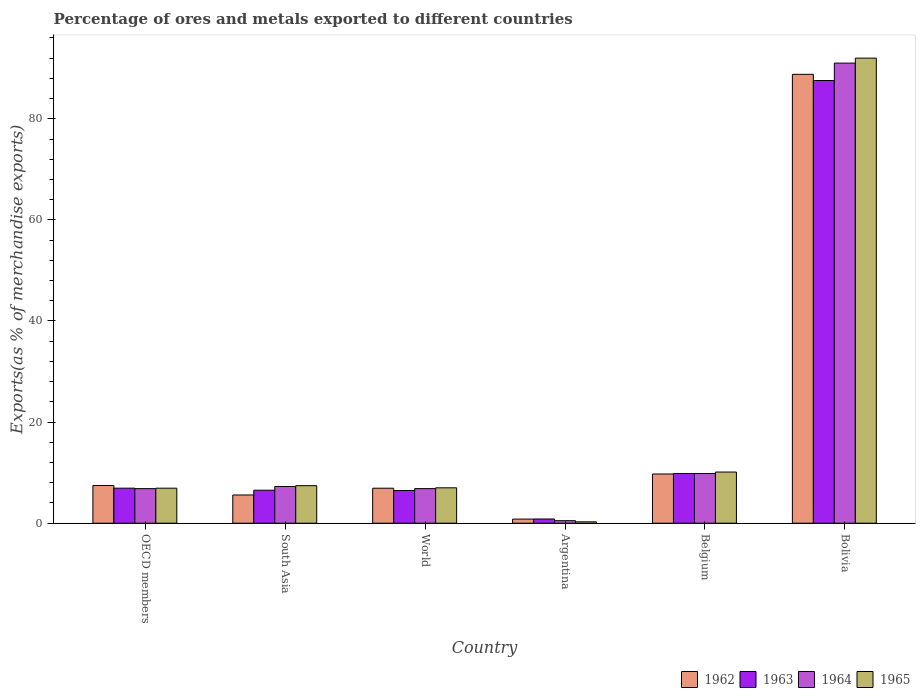How many different coloured bars are there?
Make the answer very short. 4. How many groups of bars are there?
Your response must be concise. 6. Are the number of bars per tick equal to the number of legend labels?
Offer a very short reply. Yes. How many bars are there on the 6th tick from the right?
Make the answer very short. 4. In how many cases, is the number of bars for a given country not equal to the number of legend labels?
Provide a succinct answer. 0. What is the percentage of exports to different countries in 1962 in Belgium?
Your answer should be very brief. 9.73. Across all countries, what is the maximum percentage of exports to different countries in 1965?
Your answer should be very brief. 92. Across all countries, what is the minimum percentage of exports to different countries in 1962?
Make the answer very short. 0.81. In which country was the percentage of exports to different countries in 1965 maximum?
Give a very brief answer. Bolivia. What is the total percentage of exports to different countries in 1965 in the graph?
Keep it short and to the point. 123.74. What is the difference between the percentage of exports to different countries in 1963 in Argentina and that in OECD members?
Offer a very short reply. -6.1. What is the difference between the percentage of exports to different countries in 1962 in Argentina and the percentage of exports to different countries in 1964 in South Asia?
Your response must be concise. -6.45. What is the average percentage of exports to different countries in 1963 per country?
Provide a short and direct response. 19.69. What is the difference between the percentage of exports to different countries of/in 1964 and percentage of exports to different countries of/in 1963 in World?
Offer a very short reply. 0.38. In how many countries, is the percentage of exports to different countries in 1964 greater than 56 %?
Your answer should be compact. 1. What is the ratio of the percentage of exports to different countries in 1962 in Argentina to that in Bolivia?
Keep it short and to the point. 0.01. Is the difference between the percentage of exports to different countries in 1964 in Argentina and OECD members greater than the difference between the percentage of exports to different countries in 1963 in Argentina and OECD members?
Your answer should be very brief. No. What is the difference between the highest and the second highest percentage of exports to different countries in 1962?
Your response must be concise. 79.06. What is the difference between the highest and the lowest percentage of exports to different countries in 1962?
Provide a short and direct response. 87.98. Is the sum of the percentage of exports to different countries in 1963 in South Asia and World greater than the maximum percentage of exports to different countries in 1962 across all countries?
Offer a very short reply. No. Is it the case that in every country, the sum of the percentage of exports to different countries in 1964 and percentage of exports to different countries in 1963 is greater than the sum of percentage of exports to different countries in 1965 and percentage of exports to different countries in 1962?
Make the answer very short. No. What does the 1st bar from the right in OECD members represents?
Keep it short and to the point. 1965. How many bars are there?
Provide a short and direct response. 24. Are all the bars in the graph horizontal?
Ensure brevity in your answer.  No. How many countries are there in the graph?
Give a very brief answer. 6. Are the values on the major ticks of Y-axis written in scientific E-notation?
Provide a short and direct response. No. Does the graph contain any zero values?
Your answer should be very brief. No. How are the legend labels stacked?
Keep it short and to the point. Horizontal. What is the title of the graph?
Give a very brief answer. Percentage of ores and metals exported to different countries. Does "1961" appear as one of the legend labels in the graph?
Your answer should be compact. No. What is the label or title of the X-axis?
Make the answer very short. Country. What is the label or title of the Y-axis?
Provide a short and direct response. Exports(as % of merchandise exports). What is the Exports(as % of merchandise exports) of 1962 in OECD members?
Offer a very short reply. 7.46. What is the Exports(as % of merchandise exports) in 1963 in OECD members?
Ensure brevity in your answer.  6.93. What is the Exports(as % of merchandise exports) in 1964 in OECD members?
Offer a very short reply. 6.84. What is the Exports(as % of merchandise exports) of 1965 in OECD members?
Make the answer very short. 6.93. What is the Exports(as % of merchandise exports) of 1962 in South Asia?
Keep it short and to the point. 5.58. What is the Exports(as % of merchandise exports) in 1963 in South Asia?
Your response must be concise. 6.52. What is the Exports(as % of merchandise exports) of 1964 in South Asia?
Offer a very short reply. 7.26. What is the Exports(as % of merchandise exports) in 1965 in South Asia?
Offer a very short reply. 7.42. What is the Exports(as % of merchandise exports) in 1962 in World?
Ensure brevity in your answer.  6.92. What is the Exports(as % of merchandise exports) of 1963 in World?
Ensure brevity in your answer.  6.46. What is the Exports(as % of merchandise exports) of 1964 in World?
Give a very brief answer. 6.84. What is the Exports(as % of merchandise exports) in 1965 in World?
Offer a very short reply. 7. What is the Exports(as % of merchandise exports) in 1962 in Argentina?
Your response must be concise. 0.81. What is the Exports(as % of merchandise exports) of 1963 in Argentina?
Your answer should be very brief. 0.83. What is the Exports(as % of merchandise exports) in 1964 in Argentina?
Offer a very short reply. 0.5. What is the Exports(as % of merchandise exports) of 1965 in Argentina?
Your answer should be compact. 0.27. What is the Exports(as % of merchandise exports) of 1962 in Belgium?
Your response must be concise. 9.73. What is the Exports(as % of merchandise exports) of 1963 in Belgium?
Your answer should be very brief. 9.84. What is the Exports(as % of merchandise exports) in 1964 in Belgium?
Your answer should be very brief. 9.83. What is the Exports(as % of merchandise exports) of 1965 in Belgium?
Your response must be concise. 10.12. What is the Exports(as % of merchandise exports) in 1962 in Bolivia?
Your answer should be very brief. 88.79. What is the Exports(as % of merchandise exports) of 1963 in Bolivia?
Your response must be concise. 87.57. What is the Exports(as % of merchandise exports) of 1964 in Bolivia?
Offer a terse response. 91.02. What is the Exports(as % of merchandise exports) in 1965 in Bolivia?
Provide a succinct answer. 92. Across all countries, what is the maximum Exports(as % of merchandise exports) of 1962?
Offer a very short reply. 88.79. Across all countries, what is the maximum Exports(as % of merchandise exports) in 1963?
Provide a succinct answer. 87.57. Across all countries, what is the maximum Exports(as % of merchandise exports) in 1964?
Make the answer very short. 91.02. Across all countries, what is the maximum Exports(as % of merchandise exports) of 1965?
Your response must be concise. 92. Across all countries, what is the minimum Exports(as % of merchandise exports) of 1962?
Offer a terse response. 0.81. Across all countries, what is the minimum Exports(as % of merchandise exports) of 1963?
Your answer should be very brief. 0.83. Across all countries, what is the minimum Exports(as % of merchandise exports) of 1964?
Ensure brevity in your answer.  0.5. Across all countries, what is the minimum Exports(as % of merchandise exports) of 1965?
Provide a succinct answer. 0.27. What is the total Exports(as % of merchandise exports) in 1962 in the graph?
Make the answer very short. 119.31. What is the total Exports(as % of merchandise exports) in 1963 in the graph?
Your response must be concise. 118.16. What is the total Exports(as % of merchandise exports) of 1964 in the graph?
Provide a succinct answer. 122.28. What is the total Exports(as % of merchandise exports) of 1965 in the graph?
Your answer should be very brief. 123.74. What is the difference between the Exports(as % of merchandise exports) in 1962 in OECD members and that in South Asia?
Your response must be concise. 1.88. What is the difference between the Exports(as % of merchandise exports) of 1963 in OECD members and that in South Asia?
Provide a succinct answer. 0.41. What is the difference between the Exports(as % of merchandise exports) in 1964 in OECD members and that in South Asia?
Your answer should be very brief. -0.42. What is the difference between the Exports(as % of merchandise exports) of 1965 in OECD members and that in South Asia?
Make the answer very short. -0.5. What is the difference between the Exports(as % of merchandise exports) of 1962 in OECD members and that in World?
Your response must be concise. 0.54. What is the difference between the Exports(as % of merchandise exports) of 1963 in OECD members and that in World?
Provide a short and direct response. 0.47. What is the difference between the Exports(as % of merchandise exports) of 1964 in OECD members and that in World?
Your answer should be compact. -0. What is the difference between the Exports(as % of merchandise exports) of 1965 in OECD members and that in World?
Your answer should be compact. -0.07. What is the difference between the Exports(as % of merchandise exports) of 1962 in OECD members and that in Argentina?
Provide a short and direct response. 6.65. What is the difference between the Exports(as % of merchandise exports) in 1963 in OECD members and that in Argentina?
Offer a very short reply. 6.1. What is the difference between the Exports(as % of merchandise exports) in 1964 in OECD members and that in Argentina?
Offer a terse response. 6.34. What is the difference between the Exports(as % of merchandise exports) of 1965 in OECD members and that in Argentina?
Give a very brief answer. 6.66. What is the difference between the Exports(as % of merchandise exports) of 1962 in OECD members and that in Belgium?
Your answer should be very brief. -2.27. What is the difference between the Exports(as % of merchandise exports) of 1963 in OECD members and that in Belgium?
Your response must be concise. -2.91. What is the difference between the Exports(as % of merchandise exports) of 1964 in OECD members and that in Belgium?
Your answer should be very brief. -2.99. What is the difference between the Exports(as % of merchandise exports) of 1965 in OECD members and that in Belgium?
Offer a terse response. -3.19. What is the difference between the Exports(as % of merchandise exports) of 1962 in OECD members and that in Bolivia?
Provide a succinct answer. -81.33. What is the difference between the Exports(as % of merchandise exports) of 1963 in OECD members and that in Bolivia?
Ensure brevity in your answer.  -80.64. What is the difference between the Exports(as % of merchandise exports) in 1964 in OECD members and that in Bolivia?
Ensure brevity in your answer.  -84.18. What is the difference between the Exports(as % of merchandise exports) in 1965 in OECD members and that in Bolivia?
Give a very brief answer. -85.07. What is the difference between the Exports(as % of merchandise exports) of 1962 in South Asia and that in World?
Offer a terse response. -1.34. What is the difference between the Exports(as % of merchandise exports) of 1963 in South Asia and that in World?
Your answer should be very brief. 0.06. What is the difference between the Exports(as % of merchandise exports) of 1964 in South Asia and that in World?
Give a very brief answer. 0.42. What is the difference between the Exports(as % of merchandise exports) in 1965 in South Asia and that in World?
Ensure brevity in your answer.  0.42. What is the difference between the Exports(as % of merchandise exports) of 1962 in South Asia and that in Argentina?
Your response must be concise. 4.77. What is the difference between the Exports(as % of merchandise exports) of 1963 in South Asia and that in Argentina?
Provide a short and direct response. 5.69. What is the difference between the Exports(as % of merchandise exports) in 1964 in South Asia and that in Argentina?
Keep it short and to the point. 6.76. What is the difference between the Exports(as % of merchandise exports) of 1965 in South Asia and that in Argentina?
Provide a short and direct response. 7.16. What is the difference between the Exports(as % of merchandise exports) of 1962 in South Asia and that in Belgium?
Provide a succinct answer. -4.15. What is the difference between the Exports(as % of merchandise exports) of 1963 in South Asia and that in Belgium?
Your answer should be compact. -3.32. What is the difference between the Exports(as % of merchandise exports) in 1964 in South Asia and that in Belgium?
Give a very brief answer. -2.57. What is the difference between the Exports(as % of merchandise exports) in 1965 in South Asia and that in Belgium?
Provide a short and direct response. -2.69. What is the difference between the Exports(as % of merchandise exports) in 1962 in South Asia and that in Bolivia?
Provide a succinct answer. -83.21. What is the difference between the Exports(as % of merchandise exports) in 1963 in South Asia and that in Bolivia?
Provide a succinct answer. -81.05. What is the difference between the Exports(as % of merchandise exports) in 1964 in South Asia and that in Bolivia?
Your answer should be compact. -83.76. What is the difference between the Exports(as % of merchandise exports) of 1965 in South Asia and that in Bolivia?
Provide a succinct answer. -84.58. What is the difference between the Exports(as % of merchandise exports) in 1962 in World and that in Argentina?
Your answer should be compact. 6.11. What is the difference between the Exports(as % of merchandise exports) in 1963 in World and that in Argentina?
Offer a terse response. 5.63. What is the difference between the Exports(as % of merchandise exports) in 1964 in World and that in Argentina?
Make the answer very short. 6.34. What is the difference between the Exports(as % of merchandise exports) in 1965 in World and that in Argentina?
Provide a short and direct response. 6.73. What is the difference between the Exports(as % of merchandise exports) of 1962 in World and that in Belgium?
Make the answer very short. -2.81. What is the difference between the Exports(as % of merchandise exports) of 1963 in World and that in Belgium?
Your answer should be very brief. -3.38. What is the difference between the Exports(as % of merchandise exports) in 1964 in World and that in Belgium?
Provide a succinct answer. -2.99. What is the difference between the Exports(as % of merchandise exports) of 1965 in World and that in Belgium?
Provide a short and direct response. -3.12. What is the difference between the Exports(as % of merchandise exports) of 1962 in World and that in Bolivia?
Make the answer very short. -81.87. What is the difference between the Exports(as % of merchandise exports) in 1963 in World and that in Bolivia?
Provide a short and direct response. -81.11. What is the difference between the Exports(as % of merchandise exports) in 1964 in World and that in Bolivia?
Give a very brief answer. -84.18. What is the difference between the Exports(as % of merchandise exports) in 1965 in World and that in Bolivia?
Offer a very short reply. -85. What is the difference between the Exports(as % of merchandise exports) of 1962 in Argentina and that in Belgium?
Ensure brevity in your answer.  -8.92. What is the difference between the Exports(as % of merchandise exports) of 1963 in Argentina and that in Belgium?
Provide a succinct answer. -9. What is the difference between the Exports(as % of merchandise exports) of 1964 in Argentina and that in Belgium?
Provide a short and direct response. -9.33. What is the difference between the Exports(as % of merchandise exports) in 1965 in Argentina and that in Belgium?
Provide a succinct answer. -9.85. What is the difference between the Exports(as % of merchandise exports) in 1962 in Argentina and that in Bolivia?
Give a very brief answer. -87.98. What is the difference between the Exports(as % of merchandise exports) in 1963 in Argentina and that in Bolivia?
Your answer should be very brief. -86.74. What is the difference between the Exports(as % of merchandise exports) of 1964 in Argentina and that in Bolivia?
Offer a terse response. -90.52. What is the difference between the Exports(as % of merchandise exports) of 1965 in Argentina and that in Bolivia?
Make the answer very short. -91.73. What is the difference between the Exports(as % of merchandise exports) of 1962 in Belgium and that in Bolivia?
Your answer should be compact. -79.06. What is the difference between the Exports(as % of merchandise exports) in 1963 in Belgium and that in Bolivia?
Your answer should be very brief. -77.73. What is the difference between the Exports(as % of merchandise exports) of 1964 in Belgium and that in Bolivia?
Provide a succinct answer. -81.19. What is the difference between the Exports(as % of merchandise exports) in 1965 in Belgium and that in Bolivia?
Your response must be concise. -81.88. What is the difference between the Exports(as % of merchandise exports) in 1962 in OECD members and the Exports(as % of merchandise exports) in 1963 in South Asia?
Your response must be concise. 0.94. What is the difference between the Exports(as % of merchandise exports) of 1962 in OECD members and the Exports(as % of merchandise exports) of 1964 in South Asia?
Your answer should be compact. 0.2. What is the difference between the Exports(as % of merchandise exports) of 1962 in OECD members and the Exports(as % of merchandise exports) of 1965 in South Asia?
Keep it short and to the point. 0.04. What is the difference between the Exports(as % of merchandise exports) in 1963 in OECD members and the Exports(as % of merchandise exports) in 1964 in South Asia?
Your answer should be very brief. -0.33. What is the difference between the Exports(as % of merchandise exports) of 1963 in OECD members and the Exports(as % of merchandise exports) of 1965 in South Asia?
Keep it short and to the point. -0.49. What is the difference between the Exports(as % of merchandise exports) of 1964 in OECD members and the Exports(as % of merchandise exports) of 1965 in South Asia?
Provide a succinct answer. -0.59. What is the difference between the Exports(as % of merchandise exports) of 1962 in OECD members and the Exports(as % of merchandise exports) of 1963 in World?
Offer a terse response. 1. What is the difference between the Exports(as % of merchandise exports) in 1962 in OECD members and the Exports(as % of merchandise exports) in 1964 in World?
Your answer should be compact. 0.62. What is the difference between the Exports(as % of merchandise exports) in 1962 in OECD members and the Exports(as % of merchandise exports) in 1965 in World?
Your answer should be compact. 0.46. What is the difference between the Exports(as % of merchandise exports) in 1963 in OECD members and the Exports(as % of merchandise exports) in 1964 in World?
Give a very brief answer. 0.09. What is the difference between the Exports(as % of merchandise exports) of 1963 in OECD members and the Exports(as % of merchandise exports) of 1965 in World?
Give a very brief answer. -0.07. What is the difference between the Exports(as % of merchandise exports) in 1964 in OECD members and the Exports(as % of merchandise exports) in 1965 in World?
Offer a terse response. -0.16. What is the difference between the Exports(as % of merchandise exports) of 1962 in OECD members and the Exports(as % of merchandise exports) of 1963 in Argentina?
Your answer should be very brief. 6.63. What is the difference between the Exports(as % of merchandise exports) of 1962 in OECD members and the Exports(as % of merchandise exports) of 1964 in Argentina?
Ensure brevity in your answer.  6.96. What is the difference between the Exports(as % of merchandise exports) of 1962 in OECD members and the Exports(as % of merchandise exports) of 1965 in Argentina?
Keep it short and to the point. 7.19. What is the difference between the Exports(as % of merchandise exports) in 1963 in OECD members and the Exports(as % of merchandise exports) in 1964 in Argentina?
Offer a very short reply. 6.43. What is the difference between the Exports(as % of merchandise exports) in 1963 in OECD members and the Exports(as % of merchandise exports) in 1965 in Argentina?
Ensure brevity in your answer.  6.66. What is the difference between the Exports(as % of merchandise exports) in 1964 in OECD members and the Exports(as % of merchandise exports) in 1965 in Argentina?
Give a very brief answer. 6.57. What is the difference between the Exports(as % of merchandise exports) in 1962 in OECD members and the Exports(as % of merchandise exports) in 1963 in Belgium?
Your answer should be compact. -2.38. What is the difference between the Exports(as % of merchandise exports) of 1962 in OECD members and the Exports(as % of merchandise exports) of 1964 in Belgium?
Keep it short and to the point. -2.36. What is the difference between the Exports(as % of merchandise exports) of 1962 in OECD members and the Exports(as % of merchandise exports) of 1965 in Belgium?
Offer a very short reply. -2.66. What is the difference between the Exports(as % of merchandise exports) in 1963 in OECD members and the Exports(as % of merchandise exports) in 1964 in Belgium?
Your response must be concise. -2.9. What is the difference between the Exports(as % of merchandise exports) of 1963 in OECD members and the Exports(as % of merchandise exports) of 1965 in Belgium?
Ensure brevity in your answer.  -3.19. What is the difference between the Exports(as % of merchandise exports) in 1964 in OECD members and the Exports(as % of merchandise exports) in 1965 in Belgium?
Provide a succinct answer. -3.28. What is the difference between the Exports(as % of merchandise exports) in 1962 in OECD members and the Exports(as % of merchandise exports) in 1963 in Bolivia?
Provide a short and direct response. -80.11. What is the difference between the Exports(as % of merchandise exports) in 1962 in OECD members and the Exports(as % of merchandise exports) in 1964 in Bolivia?
Provide a short and direct response. -83.56. What is the difference between the Exports(as % of merchandise exports) in 1962 in OECD members and the Exports(as % of merchandise exports) in 1965 in Bolivia?
Provide a succinct answer. -84.54. What is the difference between the Exports(as % of merchandise exports) of 1963 in OECD members and the Exports(as % of merchandise exports) of 1964 in Bolivia?
Provide a short and direct response. -84.09. What is the difference between the Exports(as % of merchandise exports) of 1963 in OECD members and the Exports(as % of merchandise exports) of 1965 in Bolivia?
Your answer should be compact. -85.07. What is the difference between the Exports(as % of merchandise exports) of 1964 in OECD members and the Exports(as % of merchandise exports) of 1965 in Bolivia?
Your answer should be very brief. -85.16. What is the difference between the Exports(as % of merchandise exports) in 1962 in South Asia and the Exports(as % of merchandise exports) in 1963 in World?
Ensure brevity in your answer.  -0.88. What is the difference between the Exports(as % of merchandise exports) of 1962 in South Asia and the Exports(as % of merchandise exports) of 1964 in World?
Offer a very short reply. -1.26. What is the difference between the Exports(as % of merchandise exports) of 1962 in South Asia and the Exports(as % of merchandise exports) of 1965 in World?
Offer a very short reply. -1.42. What is the difference between the Exports(as % of merchandise exports) of 1963 in South Asia and the Exports(as % of merchandise exports) of 1964 in World?
Offer a very short reply. -0.32. What is the difference between the Exports(as % of merchandise exports) in 1963 in South Asia and the Exports(as % of merchandise exports) in 1965 in World?
Keep it short and to the point. -0.48. What is the difference between the Exports(as % of merchandise exports) of 1964 in South Asia and the Exports(as % of merchandise exports) of 1965 in World?
Give a very brief answer. 0.26. What is the difference between the Exports(as % of merchandise exports) in 1962 in South Asia and the Exports(as % of merchandise exports) in 1963 in Argentina?
Ensure brevity in your answer.  4.75. What is the difference between the Exports(as % of merchandise exports) in 1962 in South Asia and the Exports(as % of merchandise exports) in 1964 in Argentina?
Your response must be concise. 5.08. What is the difference between the Exports(as % of merchandise exports) of 1962 in South Asia and the Exports(as % of merchandise exports) of 1965 in Argentina?
Offer a very short reply. 5.32. What is the difference between the Exports(as % of merchandise exports) in 1963 in South Asia and the Exports(as % of merchandise exports) in 1964 in Argentina?
Provide a succinct answer. 6.02. What is the difference between the Exports(as % of merchandise exports) in 1963 in South Asia and the Exports(as % of merchandise exports) in 1965 in Argentina?
Give a very brief answer. 6.25. What is the difference between the Exports(as % of merchandise exports) of 1964 in South Asia and the Exports(as % of merchandise exports) of 1965 in Argentina?
Offer a terse response. 6.99. What is the difference between the Exports(as % of merchandise exports) of 1962 in South Asia and the Exports(as % of merchandise exports) of 1963 in Belgium?
Your response must be concise. -4.25. What is the difference between the Exports(as % of merchandise exports) in 1962 in South Asia and the Exports(as % of merchandise exports) in 1964 in Belgium?
Provide a short and direct response. -4.24. What is the difference between the Exports(as % of merchandise exports) of 1962 in South Asia and the Exports(as % of merchandise exports) of 1965 in Belgium?
Your response must be concise. -4.54. What is the difference between the Exports(as % of merchandise exports) of 1963 in South Asia and the Exports(as % of merchandise exports) of 1964 in Belgium?
Give a very brief answer. -3.3. What is the difference between the Exports(as % of merchandise exports) of 1963 in South Asia and the Exports(as % of merchandise exports) of 1965 in Belgium?
Your answer should be very brief. -3.6. What is the difference between the Exports(as % of merchandise exports) of 1964 in South Asia and the Exports(as % of merchandise exports) of 1965 in Belgium?
Offer a terse response. -2.86. What is the difference between the Exports(as % of merchandise exports) of 1962 in South Asia and the Exports(as % of merchandise exports) of 1963 in Bolivia?
Offer a terse response. -81.99. What is the difference between the Exports(as % of merchandise exports) of 1962 in South Asia and the Exports(as % of merchandise exports) of 1964 in Bolivia?
Provide a short and direct response. -85.43. What is the difference between the Exports(as % of merchandise exports) in 1962 in South Asia and the Exports(as % of merchandise exports) in 1965 in Bolivia?
Offer a terse response. -86.42. What is the difference between the Exports(as % of merchandise exports) of 1963 in South Asia and the Exports(as % of merchandise exports) of 1964 in Bolivia?
Offer a very short reply. -84.49. What is the difference between the Exports(as % of merchandise exports) in 1963 in South Asia and the Exports(as % of merchandise exports) in 1965 in Bolivia?
Make the answer very short. -85.48. What is the difference between the Exports(as % of merchandise exports) of 1964 in South Asia and the Exports(as % of merchandise exports) of 1965 in Bolivia?
Offer a terse response. -84.74. What is the difference between the Exports(as % of merchandise exports) of 1962 in World and the Exports(as % of merchandise exports) of 1963 in Argentina?
Your response must be concise. 6.09. What is the difference between the Exports(as % of merchandise exports) in 1962 in World and the Exports(as % of merchandise exports) in 1964 in Argentina?
Give a very brief answer. 6.42. What is the difference between the Exports(as % of merchandise exports) of 1962 in World and the Exports(as % of merchandise exports) of 1965 in Argentina?
Offer a terse response. 6.65. What is the difference between the Exports(as % of merchandise exports) in 1963 in World and the Exports(as % of merchandise exports) in 1964 in Argentina?
Keep it short and to the point. 5.96. What is the difference between the Exports(as % of merchandise exports) of 1963 in World and the Exports(as % of merchandise exports) of 1965 in Argentina?
Give a very brief answer. 6.19. What is the difference between the Exports(as % of merchandise exports) of 1964 in World and the Exports(as % of merchandise exports) of 1965 in Argentina?
Offer a very short reply. 6.57. What is the difference between the Exports(as % of merchandise exports) of 1962 in World and the Exports(as % of merchandise exports) of 1963 in Belgium?
Offer a terse response. -2.92. What is the difference between the Exports(as % of merchandise exports) in 1962 in World and the Exports(as % of merchandise exports) in 1964 in Belgium?
Make the answer very short. -2.91. What is the difference between the Exports(as % of merchandise exports) of 1962 in World and the Exports(as % of merchandise exports) of 1965 in Belgium?
Offer a very short reply. -3.2. What is the difference between the Exports(as % of merchandise exports) of 1963 in World and the Exports(as % of merchandise exports) of 1964 in Belgium?
Provide a short and direct response. -3.37. What is the difference between the Exports(as % of merchandise exports) of 1963 in World and the Exports(as % of merchandise exports) of 1965 in Belgium?
Your answer should be compact. -3.66. What is the difference between the Exports(as % of merchandise exports) of 1964 in World and the Exports(as % of merchandise exports) of 1965 in Belgium?
Provide a short and direct response. -3.28. What is the difference between the Exports(as % of merchandise exports) in 1962 in World and the Exports(as % of merchandise exports) in 1963 in Bolivia?
Keep it short and to the point. -80.65. What is the difference between the Exports(as % of merchandise exports) of 1962 in World and the Exports(as % of merchandise exports) of 1964 in Bolivia?
Your answer should be very brief. -84.1. What is the difference between the Exports(as % of merchandise exports) of 1962 in World and the Exports(as % of merchandise exports) of 1965 in Bolivia?
Make the answer very short. -85.08. What is the difference between the Exports(as % of merchandise exports) in 1963 in World and the Exports(as % of merchandise exports) in 1964 in Bolivia?
Offer a very short reply. -84.56. What is the difference between the Exports(as % of merchandise exports) in 1963 in World and the Exports(as % of merchandise exports) in 1965 in Bolivia?
Provide a short and direct response. -85.54. What is the difference between the Exports(as % of merchandise exports) of 1964 in World and the Exports(as % of merchandise exports) of 1965 in Bolivia?
Make the answer very short. -85.16. What is the difference between the Exports(as % of merchandise exports) of 1962 in Argentina and the Exports(as % of merchandise exports) of 1963 in Belgium?
Offer a very short reply. -9.02. What is the difference between the Exports(as % of merchandise exports) in 1962 in Argentina and the Exports(as % of merchandise exports) in 1964 in Belgium?
Offer a terse response. -9.01. What is the difference between the Exports(as % of merchandise exports) in 1962 in Argentina and the Exports(as % of merchandise exports) in 1965 in Belgium?
Offer a very short reply. -9.31. What is the difference between the Exports(as % of merchandise exports) of 1963 in Argentina and the Exports(as % of merchandise exports) of 1964 in Belgium?
Provide a short and direct response. -8.99. What is the difference between the Exports(as % of merchandise exports) of 1963 in Argentina and the Exports(as % of merchandise exports) of 1965 in Belgium?
Provide a short and direct response. -9.29. What is the difference between the Exports(as % of merchandise exports) of 1964 in Argentina and the Exports(as % of merchandise exports) of 1965 in Belgium?
Provide a succinct answer. -9.62. What is the difference between the Exports(as % of merchandise exports) in 1962 in Argentina and the Exports(as % of merchandise exports) in 1963 in Bolivia?
Provide a short and direct response. -86.76. What is the difference between the Exports(as % of merchandise exports) in 1962 in Argentina and the Exports(as % of merchandise exports) in 1964 in Bolivia?
Provide a succinct answer. -90.2. What is the difference between the Exports(as % of merchandise exports) in 1962 in Argentina and the Exports(as % of merchandise exports) in 1965 in Bolivia?
Provide a succinct answer. -91.19. What is the difference between the Exports(as % of merchandise exports) of 1963 in Argentina and the Exports(as % of merchandise exports) of 1964 in Bolivia?
Ensure brevity in your answer.  -90.18. What is the difference between the Exports(as % of merchandise exports) in 1963 in Argentina and the Exports(as % of merchandise exports) in 1965 in Bolivia?
Give a very brief answer. -91.17. What is the difference between the Exports(as % of merchandise exports) of 1964 in Argentina and the Exports(as % of merchandise exports) of 1965 in Bolivia?
Ensure brevity in your answer.  -91.5. What is the difference between the Exports(as % of merchandise exports) in 1962 in Belgium and the Exports(as % of merchandise exports) in 1963 in Bolivia?
Offer a very short reply. -77.84. What is the difference between the Exports(as % of merchandise exports) of 1962 in Belgium and the Exports(as % of merchandise exports) of 1964 in Bolivia?
Provide a short and direct response. -81.28. What is the difference between the Exports(as % of merchandise exports) of 1962 in Belgium and the Exports(as % of merchandise exports) of 1965 in Bolivia?
Your response must be concise. -82.27. What is the difference between the Exports(as % of merchandise exports) in 1963 in Belgium and the Exports(as % of merchandise exports) in 1964 in Bolivia?
Keep it short and to the point. -81.18. What is the difference between the Exports(as % of merchandise exports) of 1963 in Belgium and the Exports(as % of merchandise exports) of 1965 in Bolivia?
Your answer should be very brief. -82.16. What is the difference between the Exports(as % of merchandise exports) in 1964 in Belgium and the Exports(as % of merchandise exports) in 1965 in Bolivia?
Give a very brief answer. -82.17. What is the average Exports(as % of merchandise exports) in 1962 per country?
Offer a very short reply. 19.88. What is the average Exports(as % of merchandise exports) of 1963 per country?
Keep it short and to the point. 19.69. What is the average Exports(as % of merchandise exports) of 1964 per country?
Make the answer very short. 20.38. What is the average Exports(as % of merchandise exports) of 1965 per country?
Give a very brief answer. 20.62. What is the difference between the Exports(as % of merchandise exports) of 1962 and Exports(as % of merchandise exports) of 1963 in OECD members?
Your answer should be very brief. 0.53. What is the difference between the Exports(as % of merchandise exports) of 1962 and Exports(as % of merchandise exports) of 1964 in OECD members?
Offer a terse response. 0.62. What is the difference between the Exports(as % of merchandise exports) of 1962 and Exports(as % of merchandise exports) of 1965 in OECD members?
Your response must be concise. 0.54. What is the difference between the Exports(as % of merchandise exports) of 1963 and Exports(as % of merchandise exports) of 1964 in OECD members?
Your response must be concise. 0.09. What is the difference between the Exports(as % of merchandise exports) in 1963 and Exports(as % of merchandise exports) in 1965 in OECD members?
Your response must be concise. 0. What is the difference between the Exports(as % of merchandise exports) of 1964 and Exports(as % of merchandise exports) of 1965 in OECD members?
Provide a short and direct response. -0.09. What is the difference between the Exports(as % of merchandise exports) in 1962 and Exports(as % of merchandise exports) in 1963 in South Asia?
Ensure brevity in your answer.  -0.94. What is the difference between the Exports(as % of merchandise exports) of 1962 and Exports(as % of merchandise exports) of 1964 in South Asia?
Give a very brief answer. -1.68. What is the difference between the Exports(as % of merchandise exports) of 1962 and Exports(as % of merchandise exports) of 1965 in South Asia?
Your answer should be compact. -1.84. What is the difference between the Exports(as % of merchandise exports) in 1963 and Exports(as % of merchandise exports) in 1964 in South Asia?
Your answer should be very brief. -0.74. What is the difference between the Exports(as % of merchandise exports) in 1963 and Exports(as % of merchandise exports) in 1965 in South Asia?
Provide a succinct answer. -0.9. What is the difference between the Exports(as % of merchandise exports) in 1964 and Exports(as % of merchandise exports) in 1965 in South Asia?
Offer a very short reply. -0.17. What is the difference between the Exports(as % of merchandise exports) in 1962 and Exports(as % of merchandise exports) in 1963 in World?
Your answer should be very brief. 0.46. What is the difference between the Exports(as % of merchandise exports) in 1962 and Exports(as % of merchandise exports) in 1964 in World?
Keep it short and to the point. 0.08. What is the difference between the Exports(as % of merchandise exports) of 1962 and Exports(as % of merchandise exports) of 1965 in World?
Offer a terse response. -0.08. What is the difference between the Exports(as % of merchandise exports) in 1963 and Exports(as % of merchandise exports) in 1964 in World?
Provide a short and direct response. -0.38. What is the difference between the Exports(as % of merchandise exports) of 1963 and Exports(as % of merchandise exports) of 1965 in World?
Offer a terse response. -0.54. What is the difference between the Exports(as % of merchandise exports) of 1964 and Exports(as % of merchandise exports) of 1965 in World?
Your answer should be compact. -0.16. What is the difference between the Exports(as % of merchandise exports) in 1962 and Exports(as % of merchandise exports) in 1963 in Argentina?
Give a very brief answer. -0.02. What is the difference between the Exports(as % of merchandise exports) in 1962 and Exports(as % of merchandise exports) in 1964 in Argentina?
Offer a very short reply. 0.31. What is the difference between the Exports(as % of merchandise exports) of 1962 and Exports(as % of merchandise exports) of 1965 in Argentina?
Your response must be concise. 0.54. What is the difference between the Exports(as % of merchandise exports) of 1963 and Exports(as % of merchandise exports) of 1964 in Argentina?
Your answer should be compact. 0.33. What is the difference between the Exports(as % of merchandise exports) of 1963 and Exports(as % of merchandise exports) of 1965 in Argentina?
Offer a very short reply. 0.56. What is the difference between the Exports(as % of merchandise exports) in 1964 and Exports(as % of merchandise exports) in 1965 in Argentina?
Provide a short and direct response. 0.23. What is the difference between the Exports(as % of merchandise exports) in 1962 and Exports(as % of merchandise exports) in 1963 in Belgium?
Provide a short and direct response. -0.1. What is the difference between the Exports(as % of merchandise exports) in 1962 and Exports(as % of merchandise exports) in 1964 in Belgium?
Offer a terse response. -0.09. What is the difference between the Exports(as % of merchandise exports) of 1962 and Exports(as % of merchandise exports) of 1965 in Belgium?
Offer a terse response. -0.39. What is the difference between the Exports(as % of merchandise exports) of 1963 and Exports(as % of merchandise exports) of 1964 in Belgium?
Provide a succinct answer. 0.01. What is the difference between the Exports(as % of merchandise exports) in 1963 and Exports(as % of merchandise exports) in 1965 in Belgium?
Keep it short and to the point. -0.28. What is the difference between the Exports(as % of merchandise exports) of 1964 and Exports(as % of merchandise exports) of 1965 in Belgium?
Give a very brief answer. -0.29. What is the difference between the Exports(as % of merchandise exports) of 1962 and Exports(as % of merchandise exports) of 1963 in Bolivia?
Ensure brevity in your answer.  1.22. What is the difference between the Exports(as % of merchandise exports) of 1962 and Exports(as % of merchandise exports) of 1964 in Bolivia?
Give a very brief answer. -2.22. What is the difference between the Exports(as % of merchandise exports) in 1962 and Exports(as % of merchandise exports) in 1965 in Bolivia?
Your answer should be very brief. -3.21. What is the difference between the Exports(as % of merchandise exports) of 1963 and Exports(as % of merchandise exports) of 1964 in Bolivia?
Your answer should be compact. -3.45. What is the difference between the Exports(as % of merchandise exports) of 1963 and Exports(as % of merchandise exports) of 1965 in Bolivia?
Ensure brevity in your answer.  -4.43. What is the difference between the Exports(as % of merchandise exports) of 1964 and Exports(as % of merchandise exports) of 1965 in Bolivia?
Give a very brief answer. -0.98. What is the ratio of the Exports(as % of merchandise exports) in 1962 in OECD members to that in South Asia?
Provide a short and direct response. 1.34. What is the ratio of the Exports(as % of merchandise exports) in 1964 in OECD members to that in South Asia?
Offer a terse response. 0.94. What is the ratio of the Exports(as % of merchandise exports) in 1965 in OECD members to that in South Asia?
Offer a very short reply. 0.93. What is the ratio of the Exports(as % of merchandise exports) in 1962 in OECD members to that in World?
Provide a short and direct response. 1.08. What is the ratio of the Exports(as % of merchandise exports) in 1963 in OECD members to that in World?
Ensure brevity in your answer.  1.07. What is the ratio of the Exports(as % of merchandise exports) in 1964 in OECD members to that in World?
Provide a succinct answer. 1. What is the ratio of the Exports(as % of merchandise exports) in 1962 in OECD members to that in Argentina?
Your answer should be compact. 9.17. What is the ratio of the Exports(as % of merchandise exports) in 1963 in OECD members to that in Argentina?
Offer a terse response. 8.31. What is the ratio of the Exports(as % of merchandise exports) of 1964 in OECD members to that in Argentina?
Your answer should be compact. 13.67. What is the ratio of the Exports(as % of merchandise exports) in 1965 in OECD members to that in Argentina?
Provide a short and direct response. 25.75. What is the ratio of the Exports(as % of merchandise exports) of 1962 in OECD members to that in Belgium?
Provide a short and direct response. 0.77. What is the ratio of the Exports(as % of merchandise exports) in 1963 in OECD members to that in Belgium?
Your response must be concise. 0.7. What is the ratio of the Exports(as % of merchandise exports) in 1964 in OECD members to that in Belgium?
Make the answer very short. 0.7. What is the ratio of the Exports(as % of merchandise exports) in 1965 in OECD members to that in Belgium?
Provide a succinct answer. 0.68. What is the ratio of the Exports(as % of merchandise exports) in 1962 in OECD members to that in Bolivia?
Ensure brevity in your answer.  0.08. What is the ratio of the Exports(as % of merchandise exports) in 1963 in OECD members to that in Bolivia?
Your answer should be compact. 0.08. What is the ratio of the Exports(as % of merchandise exports) of 1964 in OECD members to that in Bolivia?
Your answer should be very brief. 0.08. What is the ratio of the Exports(as % of merchandise exports) in 1965 in OECD members to that in Bolivia?
Your answer should be compact. 0.08. What is the ratio of the Exports(as % of merchandise exports) of 1962 in South Asia to that in World?
Your answer should be compact. 0.81. What is the ratio of the Exports(as % of merchandise exports) in 1963 in South Asia to that in World?
Your answer should be compact. 1.01. What is the ratio of the Exports(as % of merchandise exports) in 1964 in South Asia to that in World?
Ensure brevity in your answer.  1.06. What is the ratio of the Exports(as % of merchandise exports) of 1965 in South Asia to that in World?
Offer a terse response. 1.06. What is the ratio of the Exports(as % of merchandise exports) of 1962 in South Asia to that in Argentina?
Your response must be concise. 6.87. What is the ratio of the Exports(as % of merchandise exports) in 1963 in South Asia to that in Argentina?
Make the answer very short. 7.82. What is the ratio of the Exports(as % of merchandise exports) of 1964 in South Asia to that in Argentina?
Offer a terse response. 14.51. What is the ratio of the Exports(as % of merchandise exports) in 1965 in South Asia to that in Argentina?
Give a very brief answer. 27.6. What is the ratio of the Exports(as % of merchandise exports) in 1962 in South Asia to that in Belgium?
Offer a very short reply. 0.57. What is the ratio of the Exports(as % of merchandise exports) in 1963 in South Asia to that in Belgium?
Provide a short and direct response. 0.66. What is the ratio of the Exports(as % of merchandise exports) of 1964 in South Asia to that in Belgium?
Provide a short and direct response. 0.74. What is the ratio of the Exports(as % of merchandise exports) of 1965 in South Asia to that in Belgium?
Offer a terse response. 0.73. What is the ratio of the Exports(as % of merchandise exports) of 1962 in South Asia to that in Bolivia?
Make the answer very short. 0.06. What is the ratio of the Exports(as % of merchandise exports) in 1963 in South Asia to that in Bolivia?
Your answer should be very brief. 0.07. What is the ratio of the Exports(as % of merchandise exports) of 1964 in South Asia to that in Bolivia?
Ensure brevity in your answer.  0.08. What is the ratio of the Exports(as % of merchandise exports) in 1965 in South Asia to that in Bolivia?
Your response must be concise. 0.08. What is the ratio of the Exports(as % of merchandise exports) in 1962 in World to that in Argentina?
Offer a very short reply. 8.51. What is the ratio of the Exports(as % of merchandise exports) in 1963 in World to that in Argentina?
Your answer should be compact. 7.75. What is the ratio of the Exports(as % of merchandise exports) of 1964 in World to that in Argentina?
Provide a succinct answer. 13.67. What is the ratio of the Exports(as % of merchandise exports) of 1965 in World to that in Argentina?
Keep it short and to the point. 26.02. What is the ratio of the Exports(as % of merchandise exports) in 1962 in World to that in Belgium?
Give a very brief answer. 0.71. What is the ratio of the Exports(as % of merchandise exports) of 1963 in World to that in Belgium?
Offer a terse response. 0.66. What is the ratio of the Exports(as % of merchandise exports) in 1964 in World to that in Belgium?
Your answer should be compact. 0.7. What is the ratio of the Exports(as % of merchandise exports) in 1965 in World to that in Belgium?
Provide a succinct answer. 0.69. What is the ratio of the Exports(as % of merchandise exports) of 1962 in World to that in Bolivia?
Your response must be concise. 0.08. What is the ratio of the Exports(as % of merchandise exports) of 1963 in World to that in Bolivia?
Give a very brief answer. 0.07. What is the ratio of the Exports(as % of merchandise exports) of 1964 in World to that in Bolivia?
Offer a very short reply. 0.08. What is the ratio of the Exports(as % of merchandise exports) of 1965 in World to that in Bolivia?
Provide a short and direct response. 0.08. What is the ratio of the Exports(as % of merchandise exports) in 1962 in Argentina to that in Belgium?
Make the answer very short. 0.08. What is the ratio of the Exports(as % of merchandise exports) of 1963 in Argentina to that in Belgium?
Keep it short and to the point. 0.08. What is the ratio of the Exports(as % of merchandise exports) in 1964 in Argentina to that in Belgium?
Keep it short and to the point. 0.05. What is the ratio of the Exports(as % of merchandise exports) in 1965 in Argentina to that in Belgium?
Give a very brief answer. 0.03. What is the ratio of the Exports(as % of merchandise exports) in 1962 in Argentina to that in Bolivia?
Provide a succinct answer. 0.01. What is the ratio of the Exports(as % of merchandise exports) of 1963 in Argentina to that in Bolivia?
Provide a succinct answer. 0.01. What is the ratio of the Exports(as % of merchandise exports) in 1964 in Argentina to that in Bolivia?
Offer a terse response. 0.01. What is the ratio of the Exports(as % of merchandise exports) in 1965 in Argentina to that in Bolivia?
Provide a succinct answer. 0. What is the ratio of the Exports(as % of merchandise exports) of 1962 in Belgium to that in Bolivia?
Provide a short and direct response. 0.11. What is the ratio of the Exports(as % of merchandise exports) of 1963 in Belgium to that in Bolivia?
Ensure brevity in your answer.  0.11. What is the ratio of the Exports(as % of merchandise exports) in 1964 in Belgium to that in Bolivia?
Give a very brief answer. 0.11. What is the ratio of the Exports(as % of merchandise exports) in 1965 in Belgium to that in Bolivia?
Your answer should be compact. 0.11. What is the difference between the highest and the second highest Exports(as % of merchandise exports) of 1962?
Provide a succinct answer. 79.06. What is the difference between the highest and the second highest Exports(as % of merchandise exports) of 1963?
Give a very brief answer. 77.73. What is the difference between the highest and the second highest Exports(as % of merchandise exports) in 1964?
Make the answer very short. 81.19. What is the difference between the highest and the second highest Exports(as % of merchandise exports) in 1965?
Ensure brevity in your answer.  81.88. What is the difference between the highest and the lowest Exports(as % of merchandise exports) of 1962?
Keep it short and to the point. 87.98. What is the difference between the highest and the lowest Exports(as % of merchandise exports) of 1963?
Keep it short and to the point. 86.74. What is the difference between the highest and the lowest Exports(as % of merchandise exports) of 1964?
Your response must be concise. 90.52. What is the difference between the highest and the lowest Exports(as % of merchandise exports) of 1965?
Your answer should be compact. 91.73. 